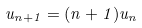<formula> <loc_0><loc_0><loc_500><loc_500>u _ { n + 1 } = ( n + 1 ) u _ { n }</formula> 